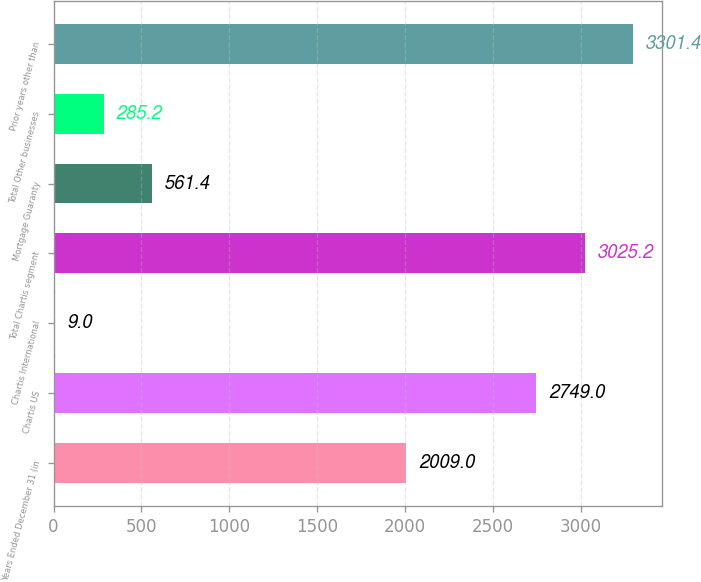Convert chart. <chart><loc_0><loc_0><loc_500><loc_500><bar_chart><fcel>Years Ended December 31 (in<fcel>Chartis US<fcel>Chartis International<fcel>Total Chartis segment<fcel>Mortgage Guaranty<fcel>Total Other businesses<fcel>Prior years other than<nl><fcel>2009<fcel>2749<fcel>9<fcel>3025.2<fcel>561.4<fcel>285.2<fcel>3301.4<nl></chart> 